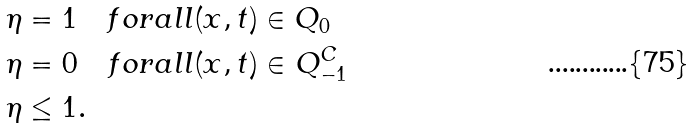Convert formula to latex. <formula><loc_0><loc_0><loc_500><loc_500>\eta & = 1 \quad f o r a l l ( x , t ) \in Q _ { 0 } \\ \eta & = 0 \quad f o r a l l ( x , t ) \in Q _ { - 1 } ^ { C } \\ \eta & \leq 1 .</formula> 